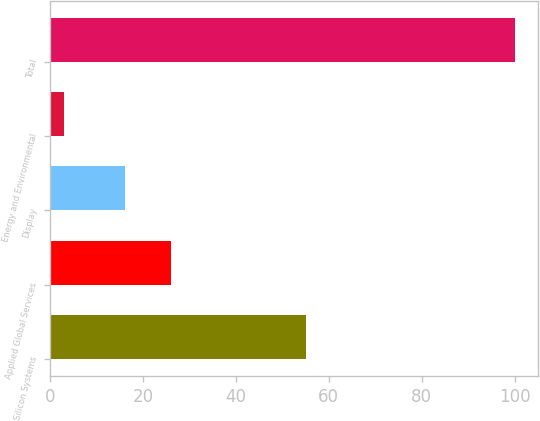<chart> <loc_0><loc_0><loc_500><loc_500><bar_chart><fcel>Silicon Systems<fcel>Applied Global Services<fcel>Display<fcel>Energy and Environmental<fcel>Total<nl><fcel>55<fcel>26<fcel>16<fcel>3<fcel>100<nl></chart> 